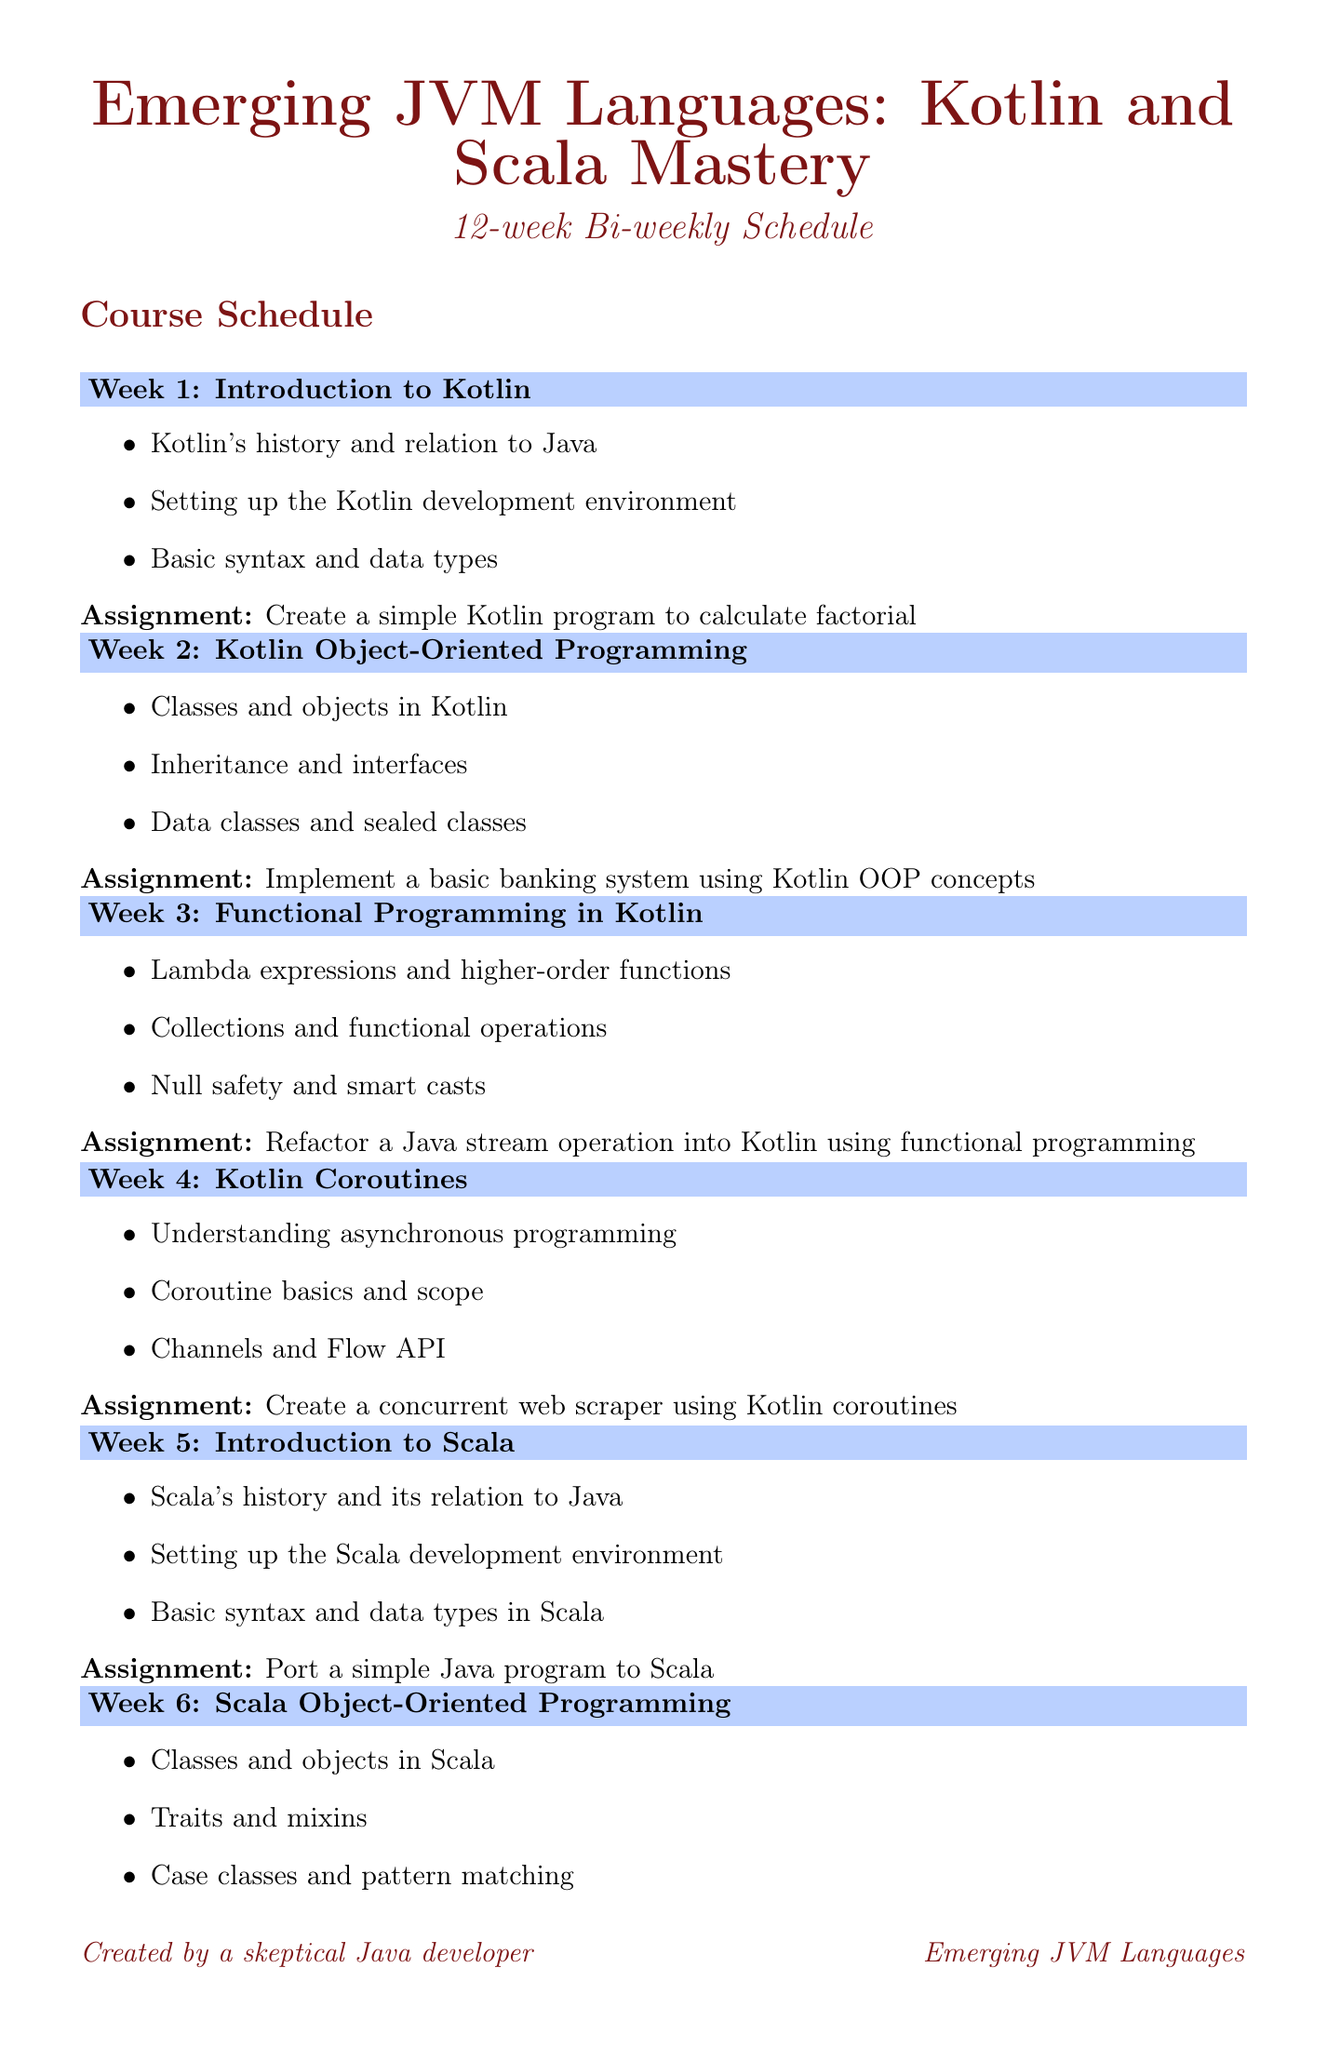What is the duration of the course? The duration is explicitly mentioned in the document as 12 weeks.
Answer: 12 weeks How often does the course meet? The schedule specifies that it occurs bi-weekly.
Answer: Bi-weekly What is the topic of week 4? The document lists the topic for week 4 as Kotlin Coroutines.
Answer: Kotlin Coroutines What type of programming is introduced in week 5? Week 5 introduces Scala, which is mentioned in the title of that week.
Answer: Scala What is the assignment for week 9? The document clearly states that the assignment is to write a report comparing Kotlin and Scala.
Answer: Write a report comparing Kotlin and Scala for a specific use case Which two languages are compared in week 9? The comparison noted in week 9 involves Kotlin and Scala.
Answer: Kotlin and Scala What is the focus of the final week's topic? The last week focuses on the future of JVM languages.
Answer: Future of JVM Languages What is the first lesson under the topic of Kotlin in week 1? The first lesson focuses on Kotlin's history and relation to Java.
Answer: Kotlin's history and relation to Java What is the resource linked that discusses Kotlin? The linked resource that discusses Kotlin is named JetBrains Kotlin Documentation.
Answer: JetBrains Kotlin Documentation 